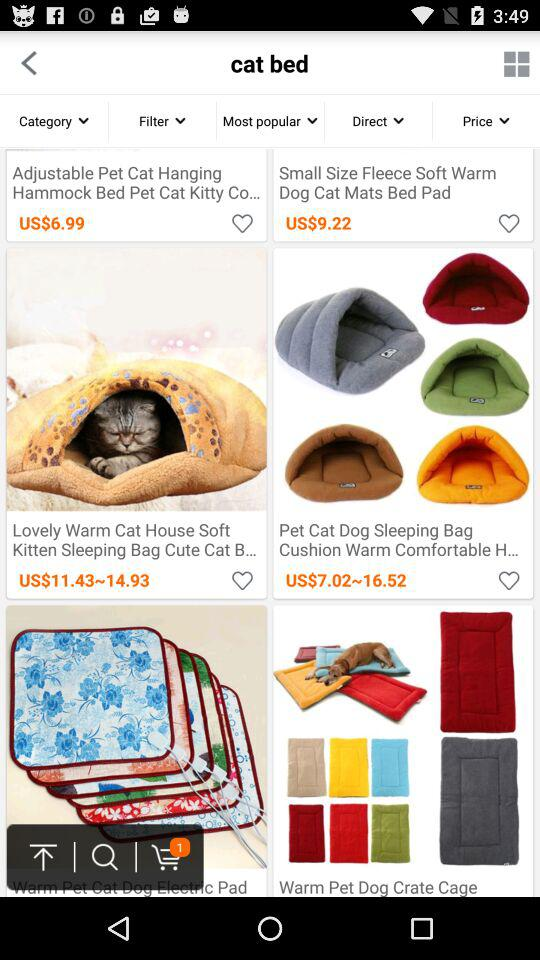How many items are in the cart? There is 1 item in the cart. 